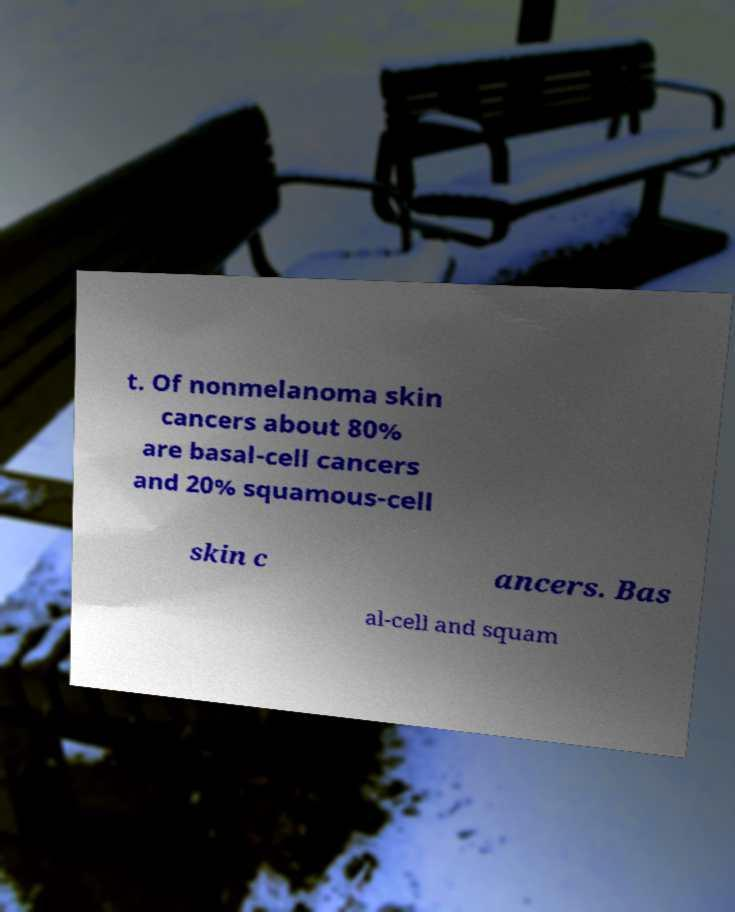Please identify and transcribe the text found in this image. t. Of nonmelanoma skin cancers about 80% are basal-cell cancers and 20% squamous-cell skin c ancers. Bas al-cell and squam 